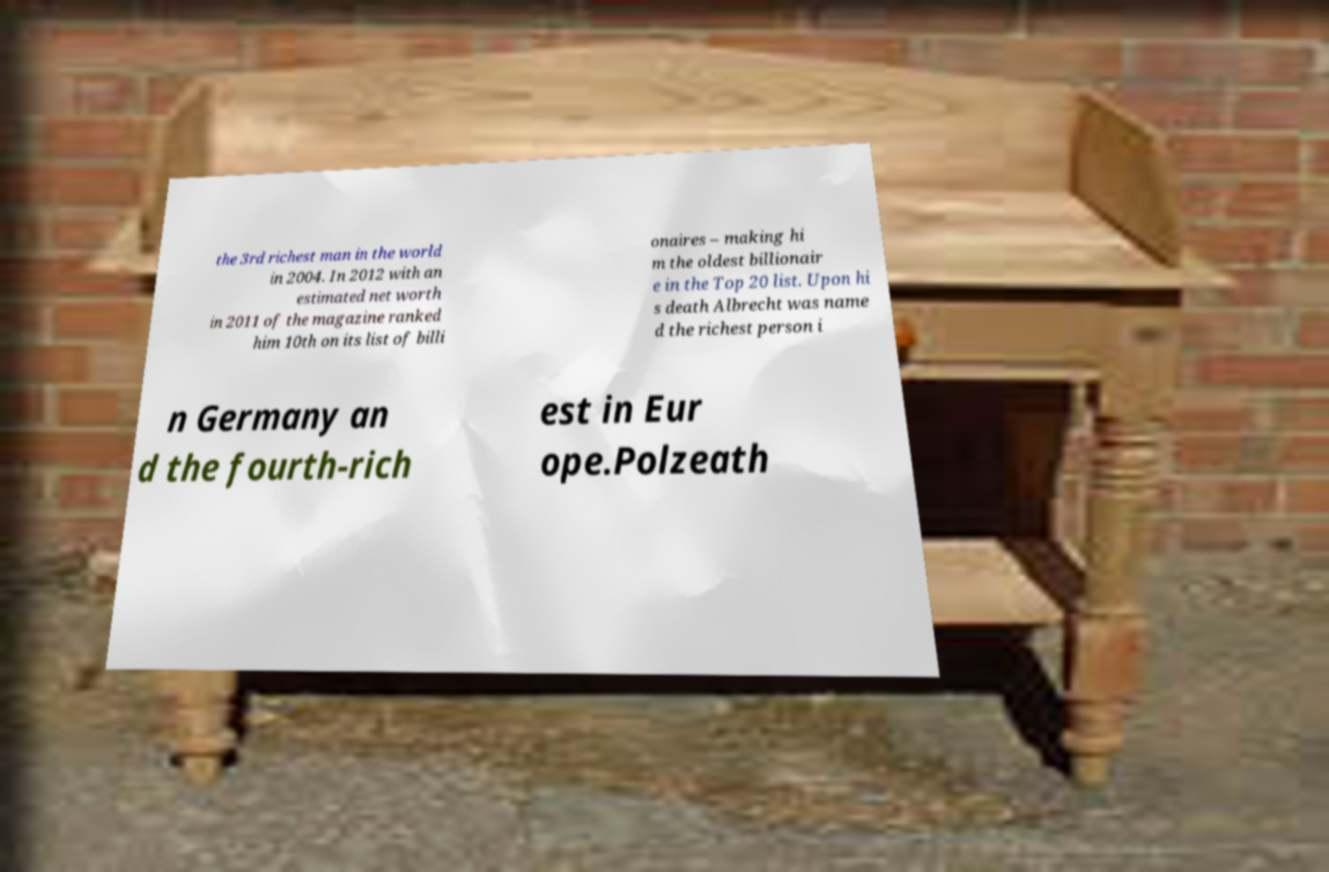Could you assist in decoding the text presented in this image and type it out clearly? the 3rd richest man in the world in 2004. In 2012 with an estimated net worth in 2011 of the magazine ranked him 10th on its list of billi onaires – making hi m the oldest billionair e in the Top 20 list. Upon hi s death Albrecht was name d the richest person i n Germany an d the fourth-rich est in Eur ope.Polzeath 